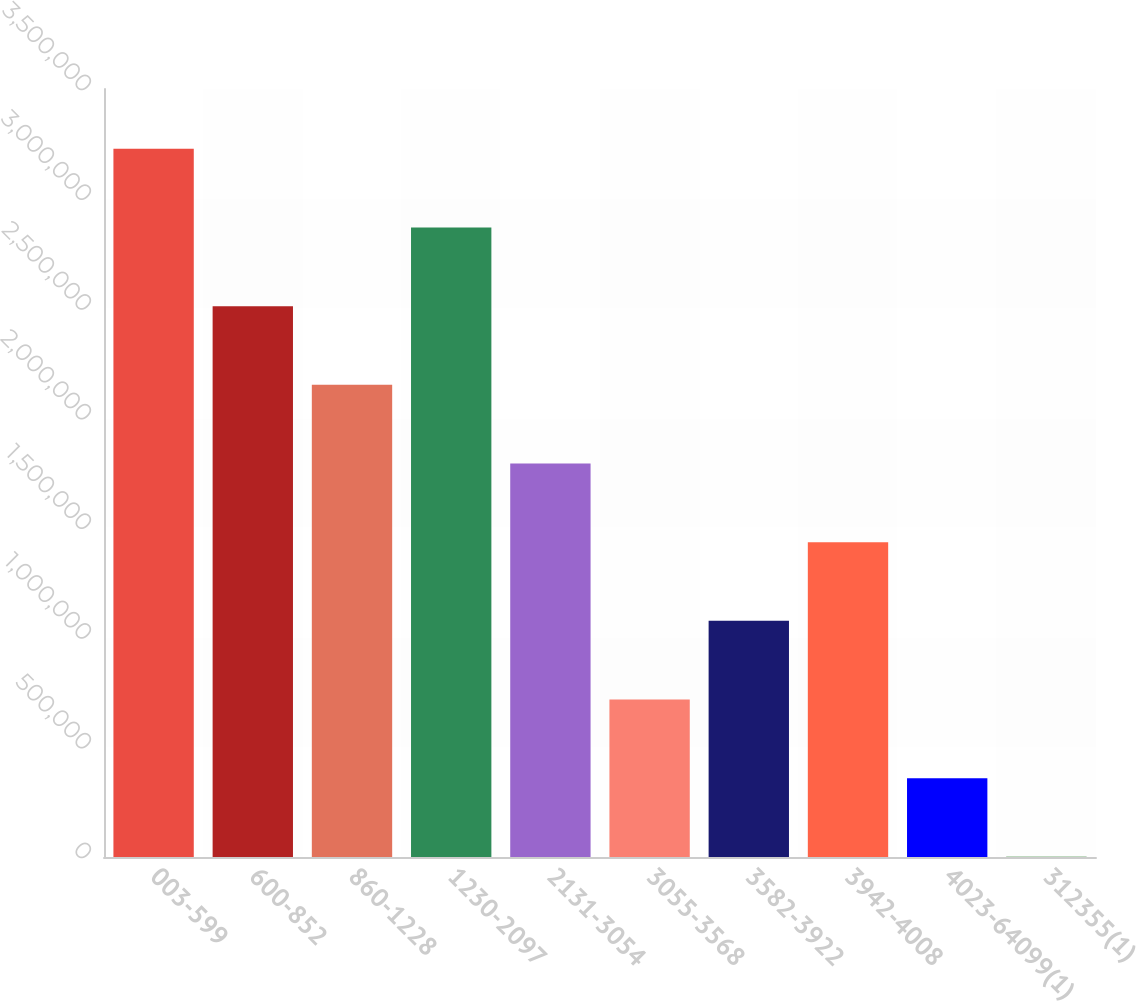Convert chart to OTSL. <chart><loc_0><loc_0><loc_500><loc_500><bar_chart><fcel>003-599<fcel>600-852<fcel>860-1228<fcel>1230-2097<fcel>2131-3054<fcel>3055-3568<fcel>3582-3922<fcel>3942-4008<fcel>4023-64099(1)<fcel>312355(1)<nl><fcel>3.22726e+06<fcel>2.51022e+06<fcel>2.15171e+06<fcel>2.86874e+06<fcel>1.79319e+06<fcel>717646<fcel>1.07616e+06<fcel>1.43468e+06<fcel>359130<fcel>614<nl></chart> 